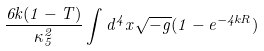<formula> <loc_0><loc_0><loc_500><loc_500>\frac { 6 k ( 1 - T ) } { \kappa _ { 5 } ^ { 2 } } \int d ^ { 4 } x \sqrt { - g } ( 1 - e ^ { - 4 k R } )</formula> 